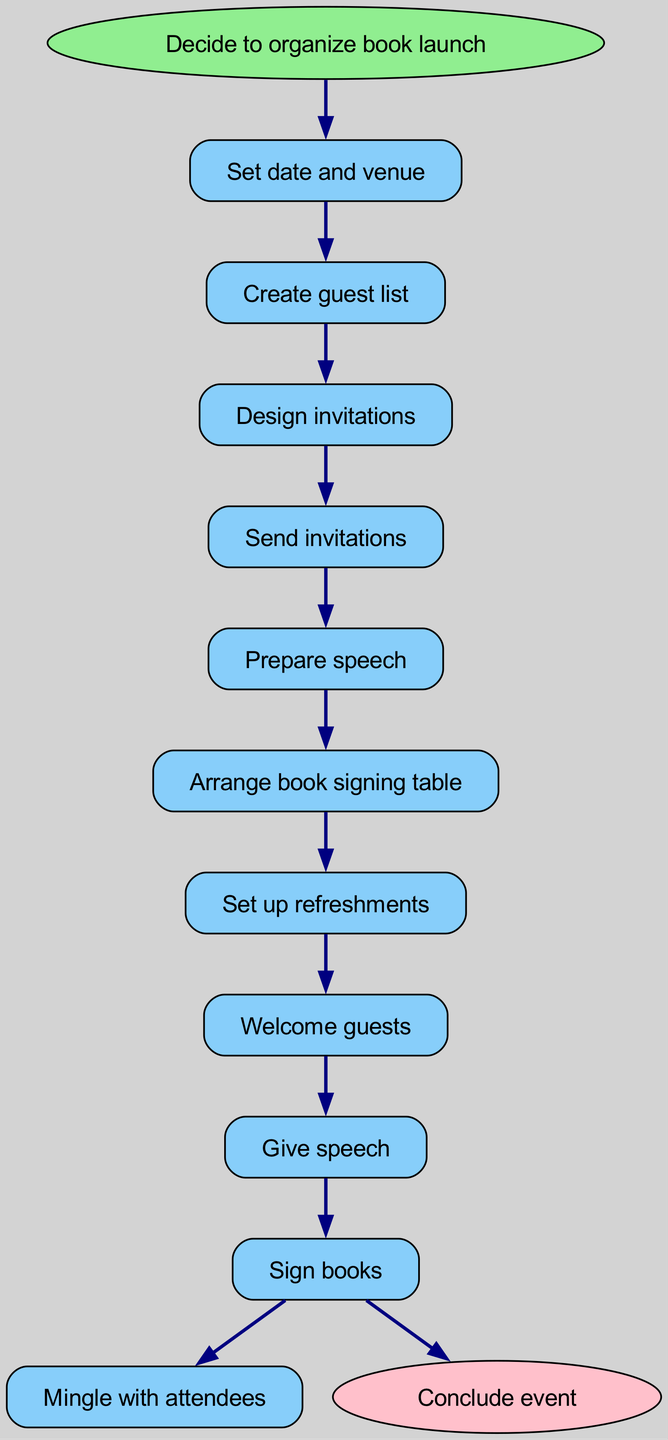What is the starting point of the event? The starting point of the event is 'Decide to organize book launch', which is indicated as the first node before any of the steps begin.
Answer: Decide to organize book launch How many total steps are there from start to end? There are 10 steps listed in the flow from the starting node to the ending node, starting with 'Set date and venue' and ending with 'Sign books'.
Answer: 10 What is the last action before concluding the event? The last action before concluding the event is 'Sign books', as indicated by the flow of steps leading up to the end node.
Answer: Sign books Which step directly follows 'Send invitations'? The step that directly follows 'Send invitations' is 'Prepare speech', as shown by the connection leading towards it.
Answer: Prepare speech What color represents the end node in the diagram? The end node, which is labeled 'Conclude event', is represented in pink color according to the visual attributes set for the end node.
Answer: Pink What step comes immediately after 'Welcome guests'? The step that comes immediately after 'Welcome guests' is 'Give speech', as indicated by the arrow directing from 'Welcome guests' to 'Give speech'.
Answer: Give speech How many edges are present in the flow chart? There are 10 edges in the flow chart, connecting each step in a sequential manner from the starting point to the end point.
Answer: 10 Which step is the first action taken after setting the date and venue? The first action taken after setting the date and venue is 'Create guest list', as this is the next step following the initial one.
Answer: Create guest list What is the flow direction indicated in the diagram? The flow direction in the diagram is top to bottom, as indicated by the arrangement and connections of the nodes throughout the chart.
Answer: Top to bottom 